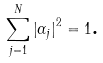Convert formula to latex. <formula><loc_0><loc_0><loc_500><loc_500>\sum _ { j = 1 } ^ { N } \left | \alpha _ { j } \right | ^ { 2 } = 1 \text {.}</formula> 